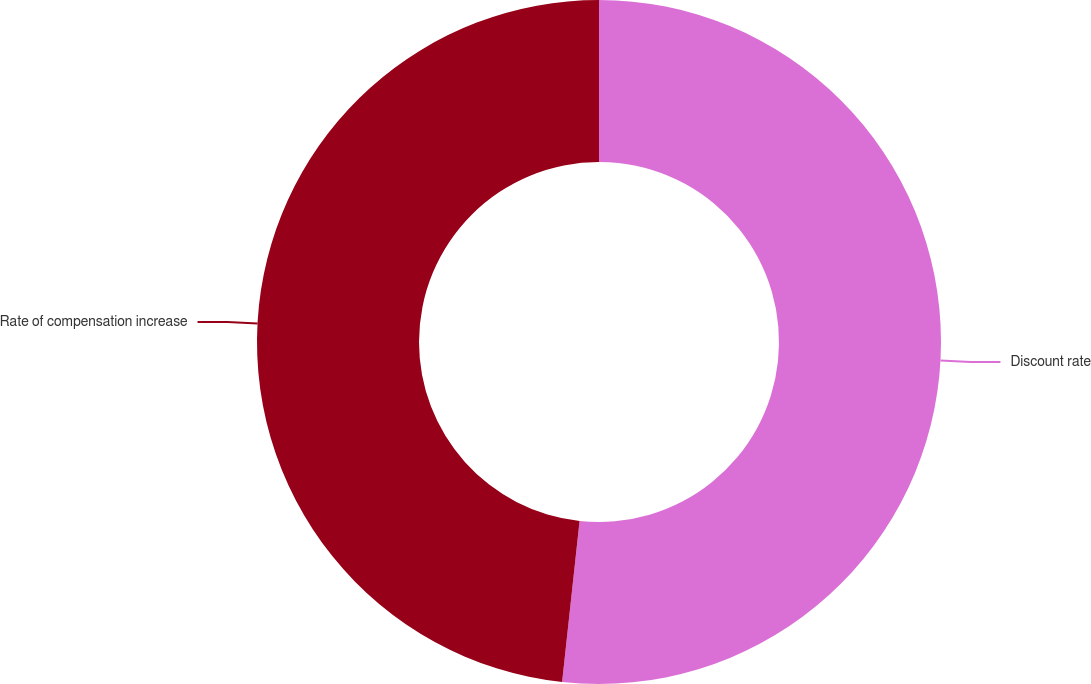Convert chart. <chart><loc_0><loc_0><loc_500><loc_500><pie_chart><fcel>Discount rate<fcel>Rate of compensation increase<nl><fcel>51.72%<fcel>48.28%<nl></chart> 